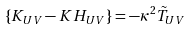<formula> <loc_0><loc_0><loc_500><loc_500>\left \{ K _ { U V } - K H _ { U V } \right \} = - \kappa ^ { 2 } \tilde { T } _ { U V }</formula> 